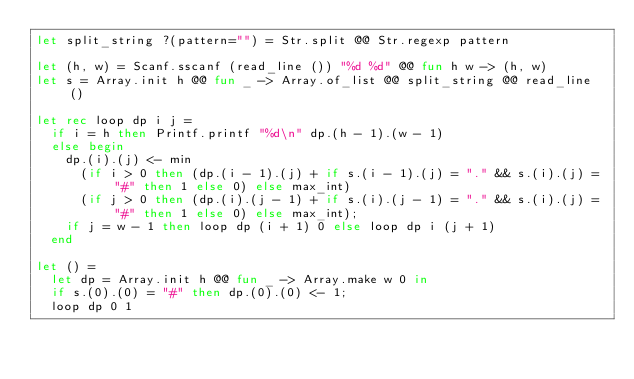Convert code to text. <code><loc_0><loc_0><loc_500><loc_500><_OCaml_>let split_string ?(pattern="") = Str.split @@ Str.regexp pattern

let (h, w) = Scanf.sscanf (read_line ()) "%d %d" @@ fun h w -> (h, w)
let s = Array.init h @@ fun _ -> Array.of_list @@ split_string @@ read_line ()

let rec loop dp i j =
  if i = h then Printf.printf "%d\n" dp.(h - 1).(w - 1)
  else begin
    dp.(i).(j) <- min
      (if i > 0 then (dp.(i - 1).(j) + if s.(i - 1).(j) = "." && s.(i).(j) = "#" then 1 else 0) else max_int)
      (if j > 0 then (dp.(i).(j - 1) + if s.(i).(j - 1) = "." && s.(i).(j) = "#" then 1 else 0) else max_int);
    if j = w - 1 then loop dp (i + 1) 0 else loop dp i (j + 1)
  end

let () =
  let dp = Array.init h @@ fun _ -> Array.make w 0 in
  if s.(0).(0) = "#" then dp.(0).(0) <- 1;
  loop dp 0 1</code> 